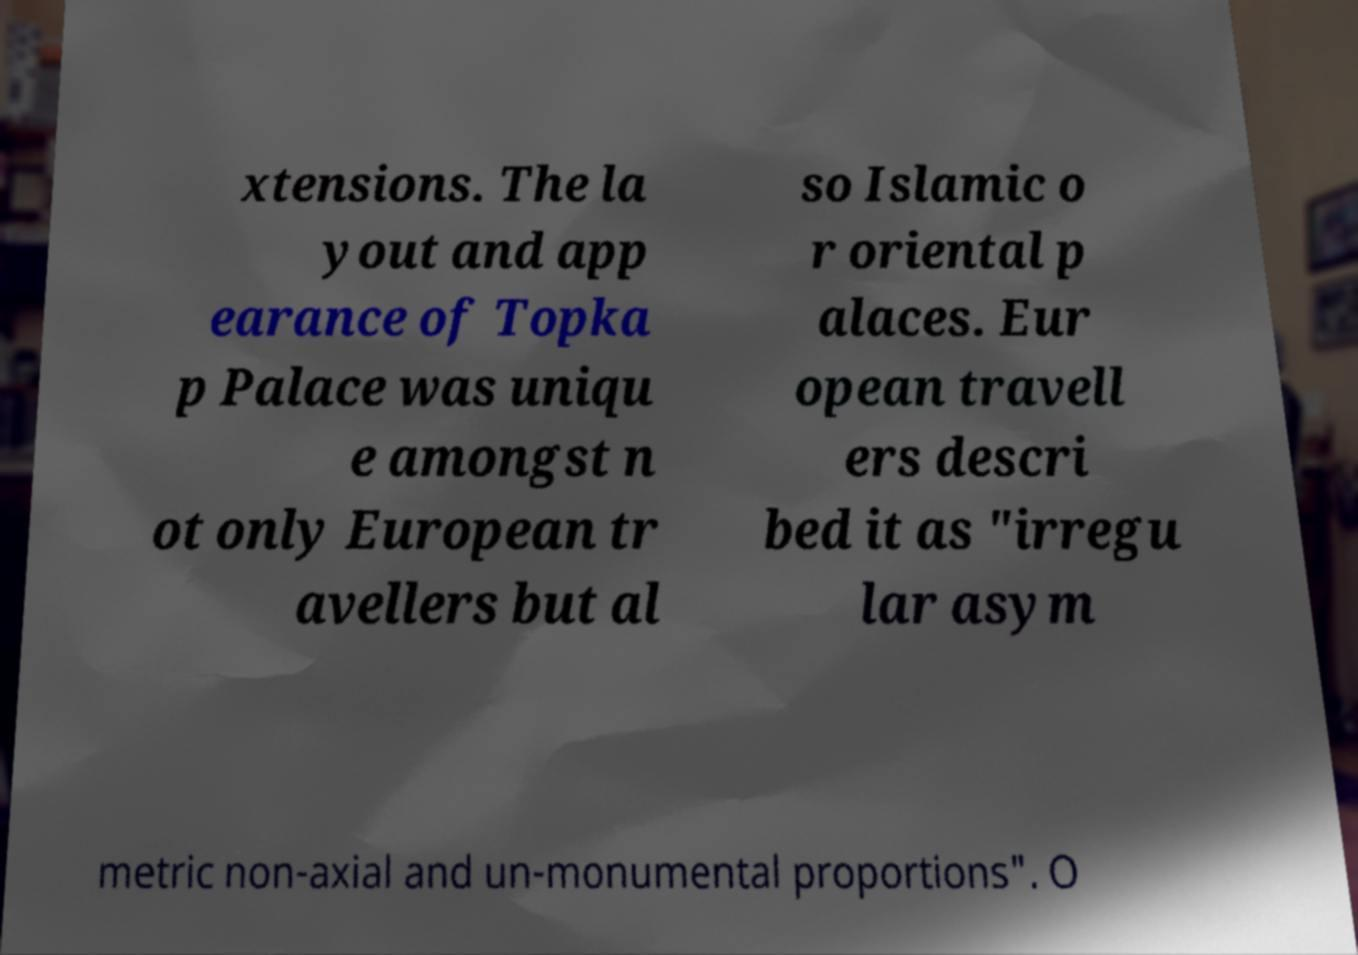What messages or text are displayed in this image? I need them in a readable, typed format. xtensions. The la yout and app earance of Topka p Palace was uniqu e amongst n ot only European tr avellers but al so Islamic o r oriental p alaces. Eur opean travell ers descri bed it as "irregu lar asym metric non-axial and un-monumental proportions". O 